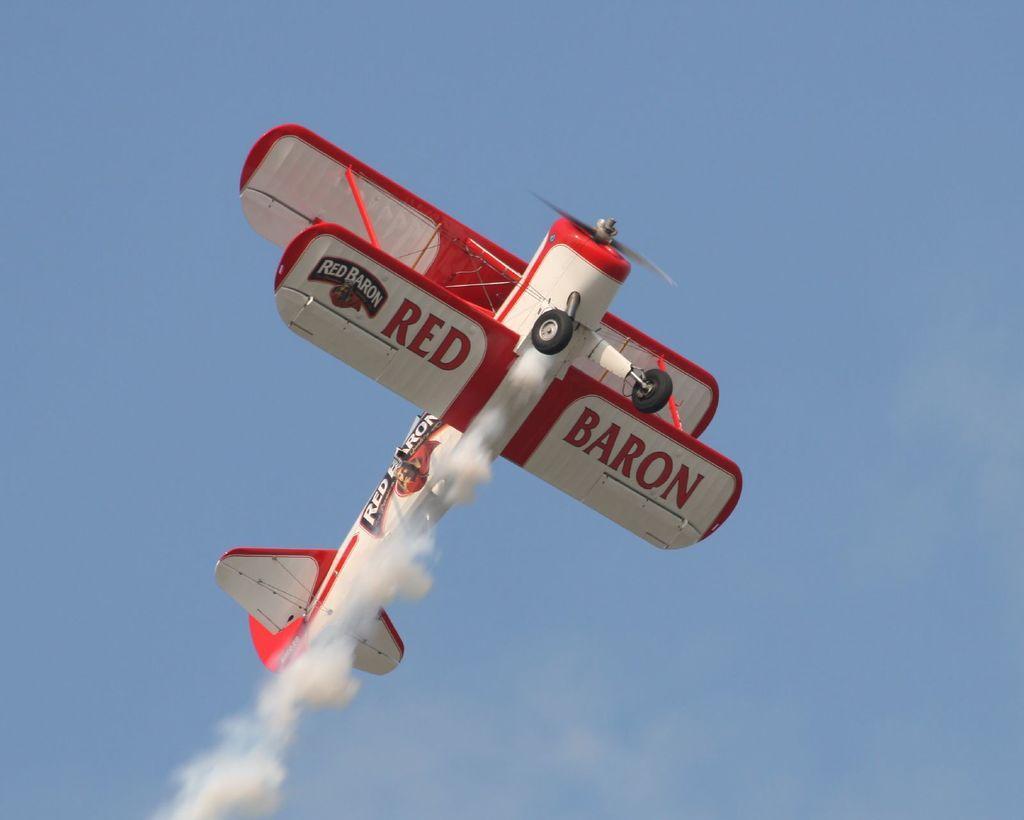Please provide a concise description of this image. In this image I can see an aircraft is flying in the air. The aircraft is in white and red color and I can see the smoke and the sky is in blue color. 